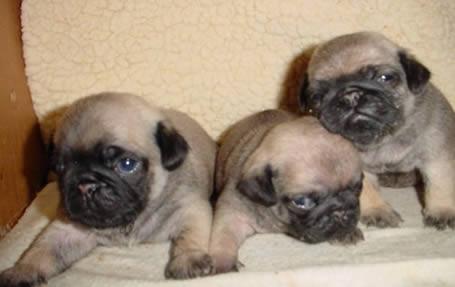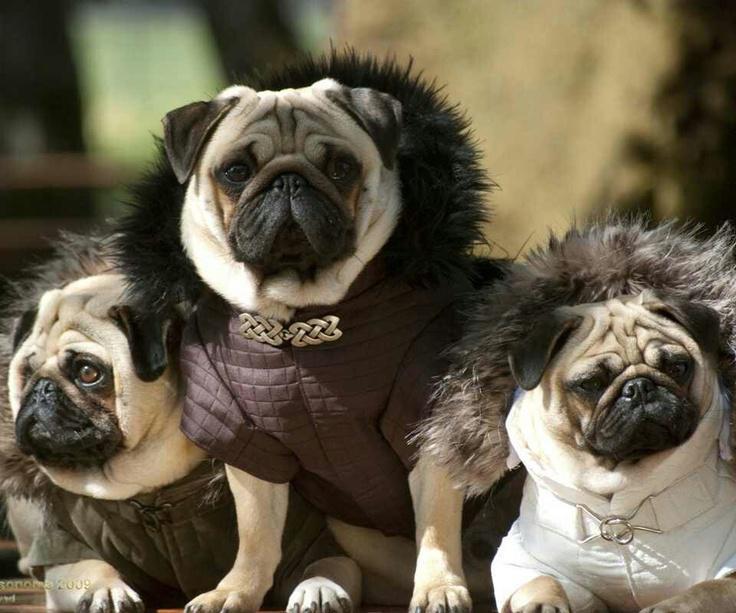The first image is the image on the left, the second image is the image on the right. Considering the images on both sides, is "Three pugs are posed in a row wearing outfits with fur collars." valid? Answer yes or no. Yes. The first image is the image on the left, the second image is the image on the right. For the images displayed, is the sentence "The dogs in the image on the right are wearing winter coats." factually correct? Answer yes or no. Yes. 